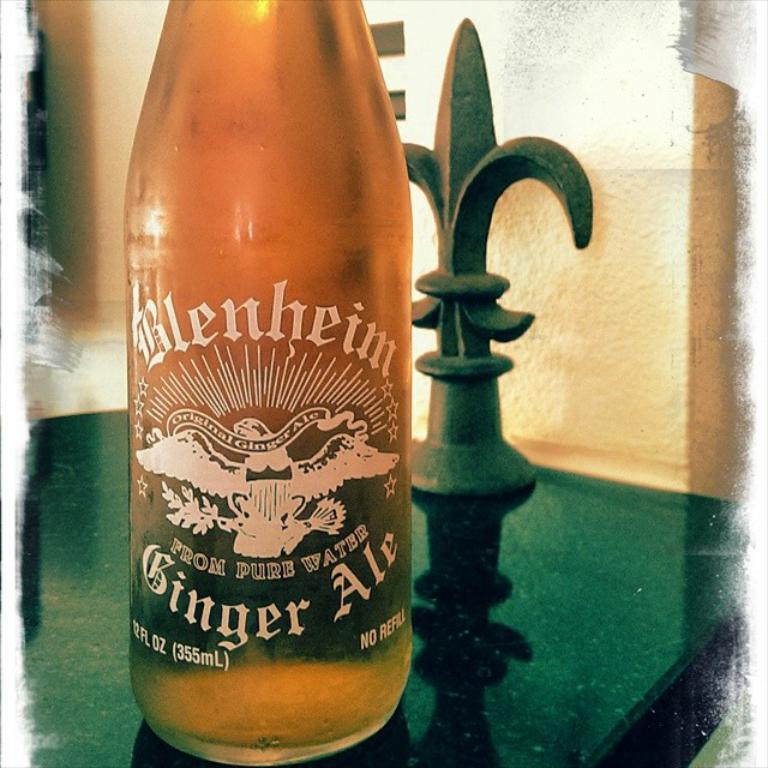<image>
Render a clear and concise summary of the photo. A bottle of Blenheim ginger Ale which is still full. 